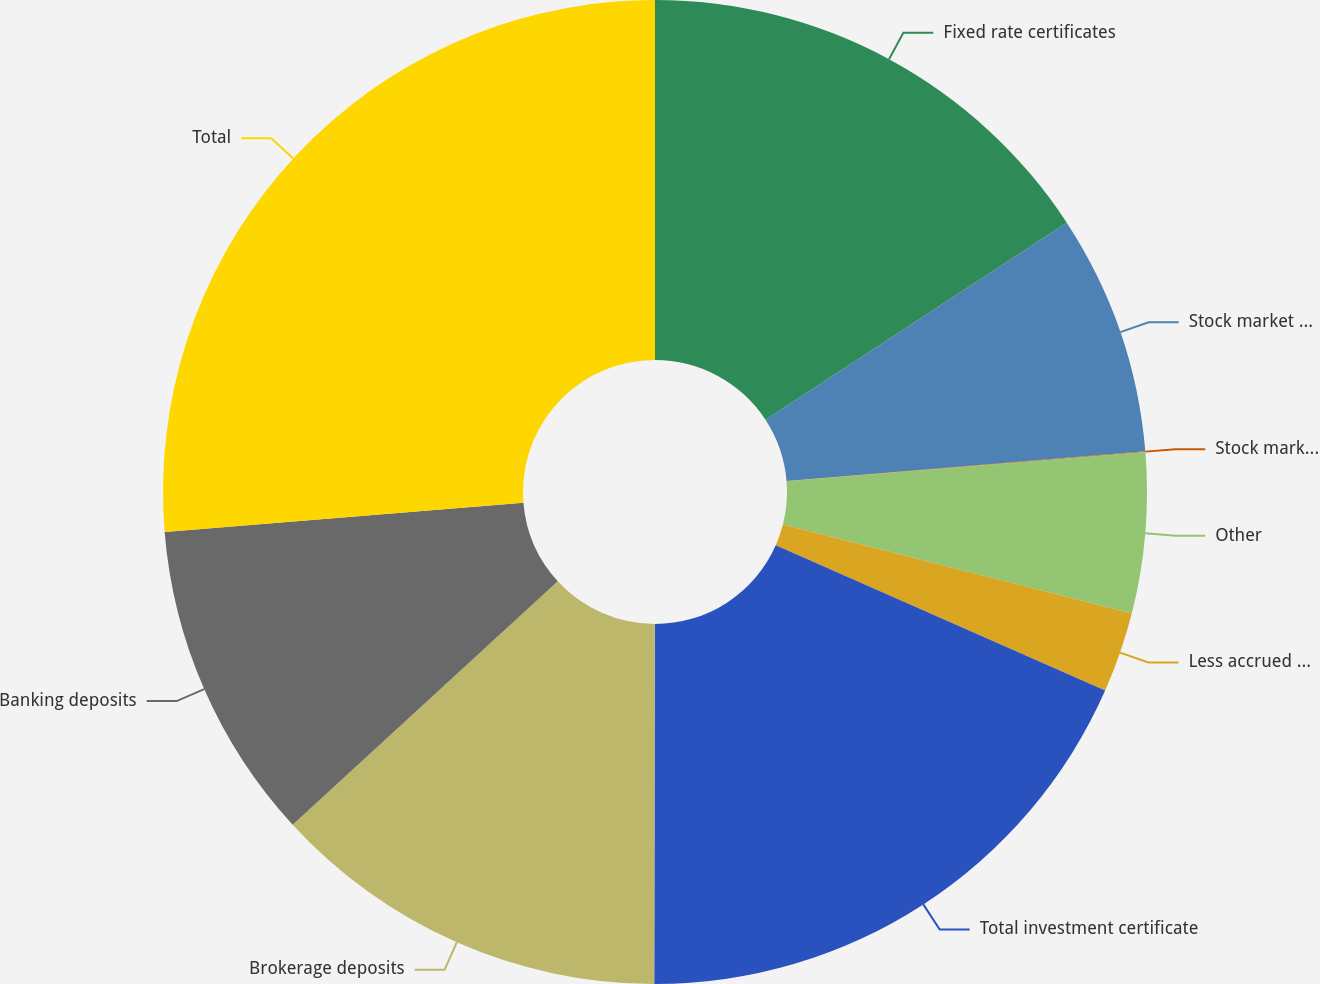Convert chart to OTSL. <chart><loc_0><loc_0><loc_500><loc_500><pie_chart><fcel>Fixed rate certificates<fcel>Stock market based<fcel>Stock market embedded<fcel>Other<fcel>Less accrued interest<fcel>Total investment certificate<fcel>Brokerage deposits<fcel>Banking deposits<fcel>Total<nl><fcel>15.78%<fcel>7.9%<fcel>0.02%<fcel>5.27%<fcel>2.64%<fcel>18.41%<fcel>13.15%<fcel>10.53%<fcel>26.29%<nl></chart> 